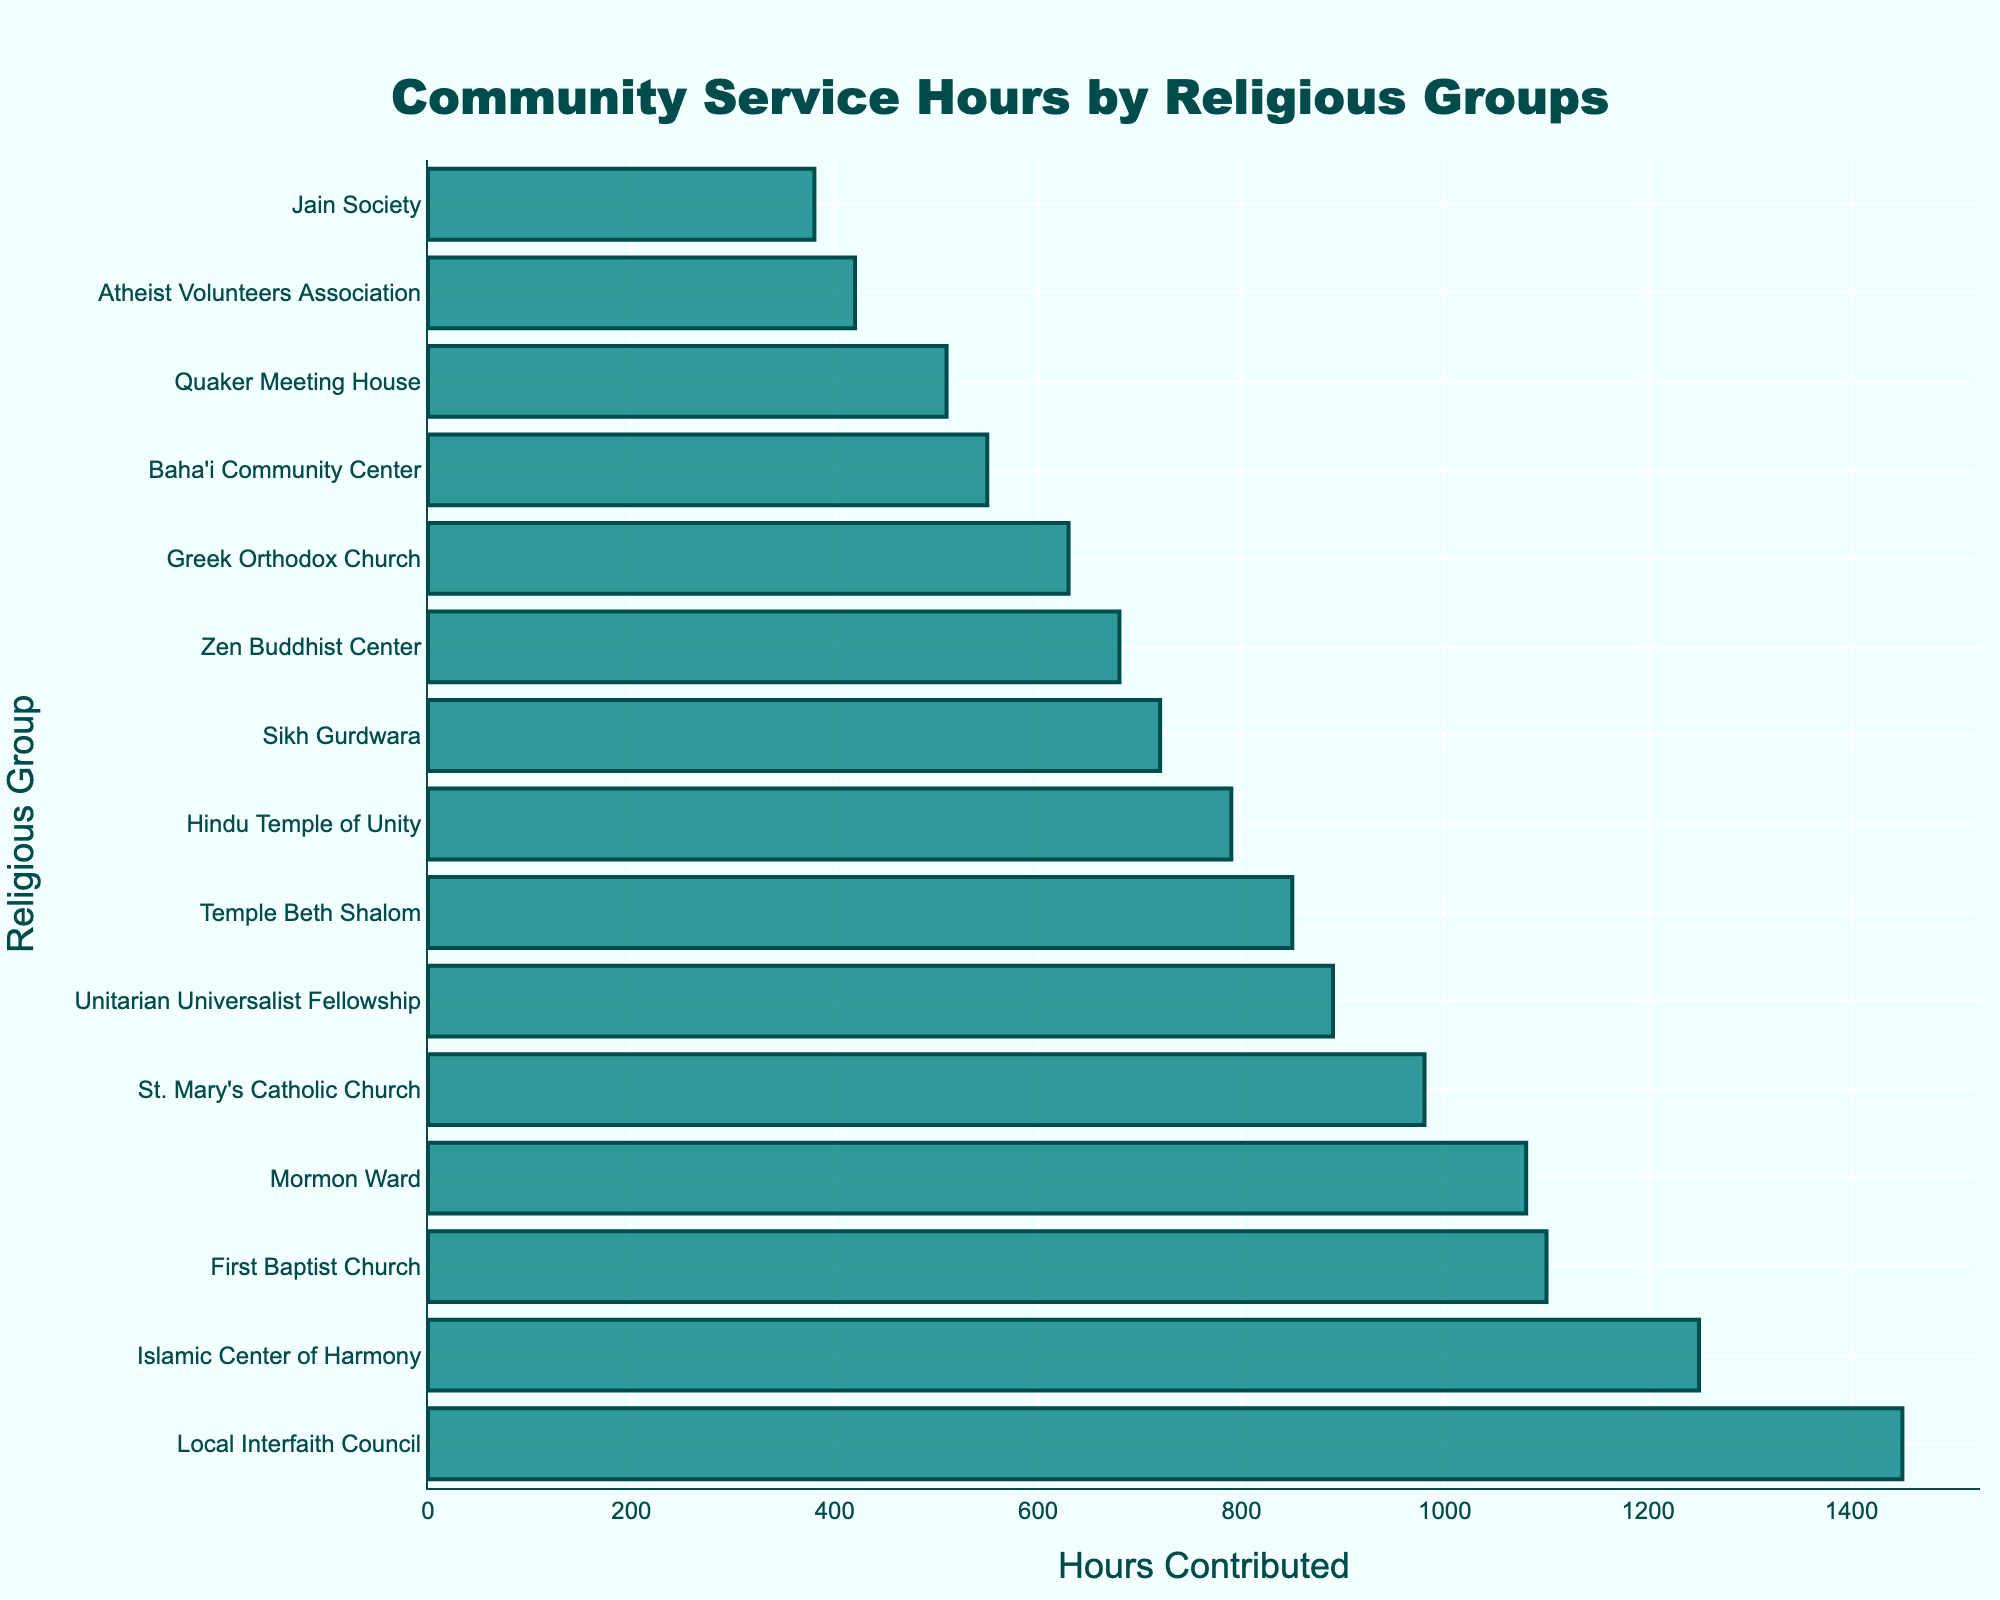Which group contributed the most community service hours? To determine the group that contributed the most hours, we look at the bar chart and identify the tallest bar. The tallest bar represents the Local Interfaith Council.
Answer: Local Interfaith Council Which religious group contributed fewer hours than the Greek Orthodox Church but more than the Baha'i Community Center? From the bar chart, we find that the Greek Orthodox Church contributed 630 hours and the Baha'i Community Center contributed 550 hours. The group between these contributions is the Unitarian Universalist Fellowship with 890 hours.
Answer: Unitarian Universalist Fellowship What are the total hours contributed by Islamic Center of Harmony and St. Mary's Catholic Church? Add the hours contributed by the Islamic Center of Harmony (1250) and St. Mary's Catholic Church (980): 1250 + 980 = 2230.
Answer: 2230 Which groups contributed exactly more than 1000 hours? From the bar chart, the groups contributing more than 1000 hours are: Islamic Center of Harmony (1250), First Baptist Church (1100), Local Interfaith Council (1450), and Mormon Ward (1080).
Answer: Islamic Center of Harmony, First Baptist Church, Local Interfaith Council, Mormon Ward What is the difference in community service hours between the Temple Beth Shalom and Sikh Gurdwara? The hours contributed by Temple Beth Shalom are 850 and by the Sikh Gurdwara are 720. The difference is 850 - 720 = 130.
Answer: 130 